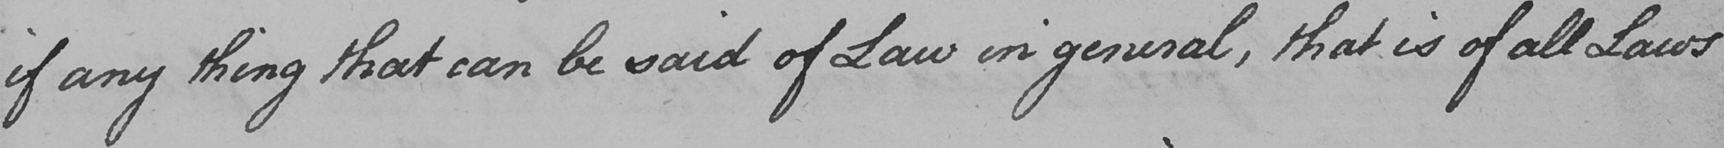Please provide the text content of this handwritten line. if any thing that can be said of Law in general , that is of all Laws 